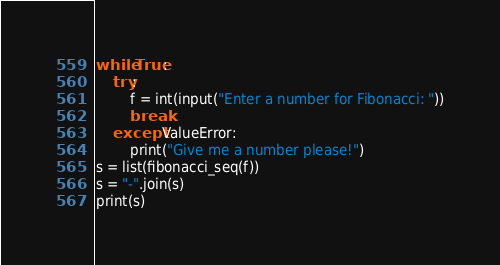<code> <loc_0><loc_0><loc_500><loc_500><_Python_>while True:
    try:
        f = int(input("Enter a number for Fibonacci: "))
        break
    except ValueError:
        print("Give me a number please!")
s = list(fibonacci_seq(f))
s = "-".join(s)
print(s)
</code> 